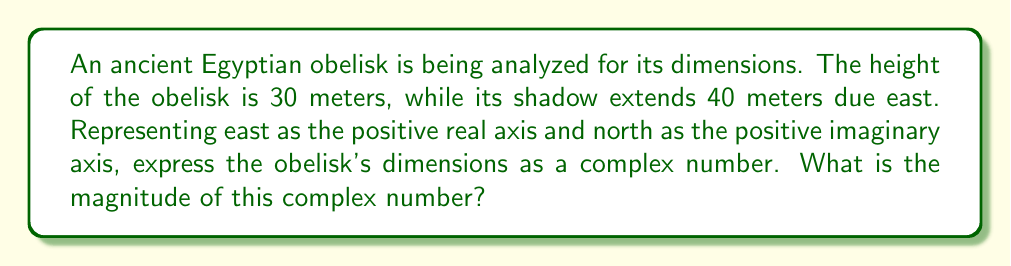Show me your answer to this math problem. Let's approach this step-by-step:

1) In the complex plane, we can represent the obelisk's dimensions as follows:
   - The shadow length (40 meters east) is represented by the real part.
   - The height (30 meters up) is represented by the imaginary part.

2) Therefore, we can express the obelisk's dimensions as the complex number:
   $z = 40 + 30i$

3) To find the magnitude of this complex number, we use the formula:
   $|z| = \sqrt{a^2 + b^2}$, where $a$ is the real part and $b$ is the imaginary part.

4) Substituting our values:
   $|z| = \sqrt{40^2 + 30^2}$

5) Simplify:
   $|z| = \sqrt{1600 + 900}$
   $|z| = \sqrt{2500}$

6) Simplify the square root:
   $|z| = 50$

Therefore, the magnitude of the complex number representing the obelisk's dimensions is 50 meters.
Answer: $50$ meters 